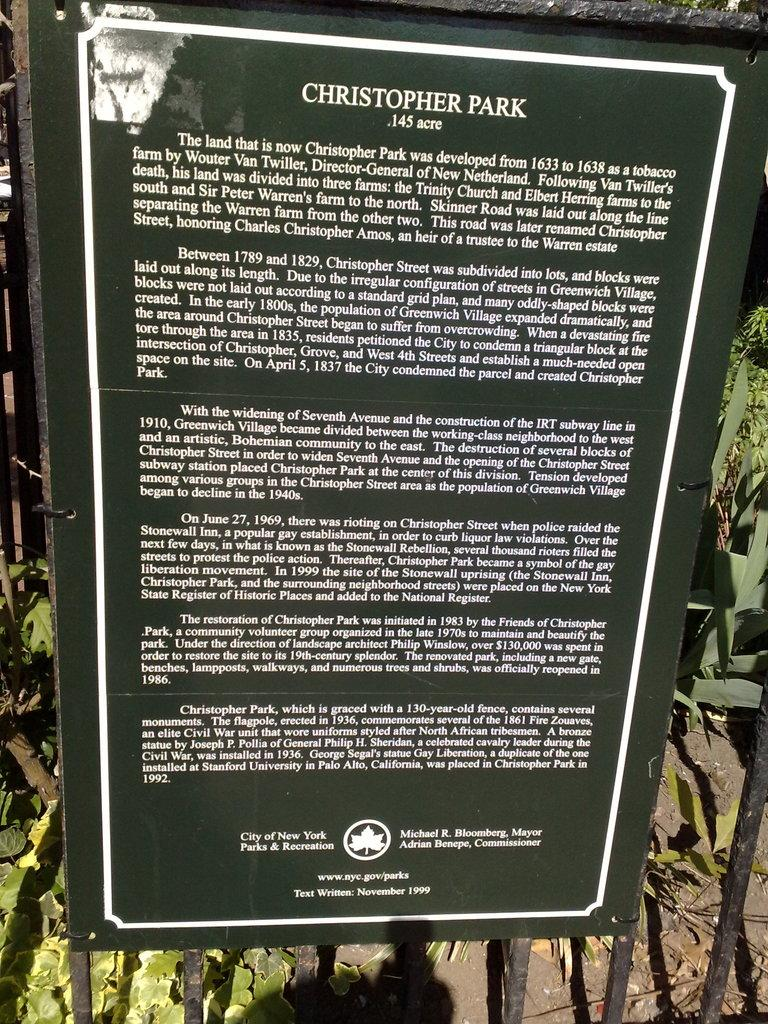What is the main subject of the image? The main subject of the image is texts written on a board. What can be seen in the background of the image? There are plants and poles visible in the background of the image. Where is the faucet located in the image? There is no faucet present in the image. 